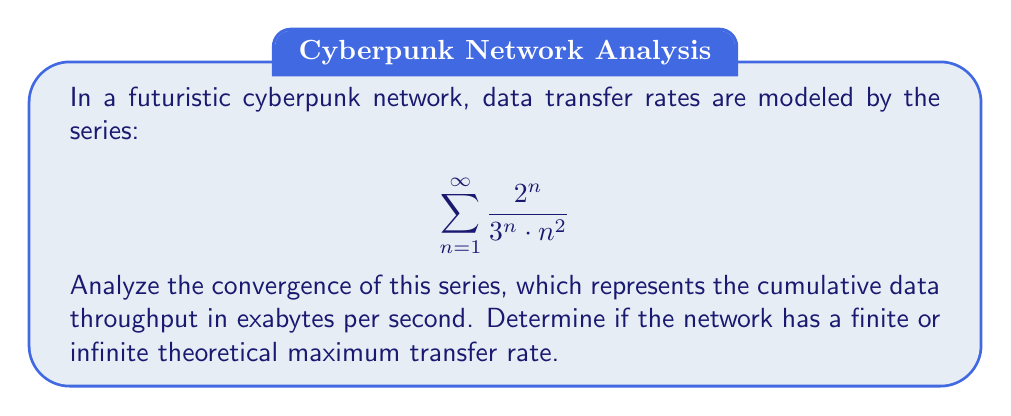Teach me how to tackle this problem. To analyze the convergence of this series, we'll use the ratio test:

1) First, let's define $a_n = \frac{2^n}{3^n \cdot n^2}$

2) Now, we compute the limit of the ratio of consecutive terms:

   $$\lim_{n \to \infty} \left|\frac{a_{n+1}}{a_n}\right| = \lim_{n \to \infty} \left|\frac{\frac{2^{n+1}}{3^{n+1} \cdot (n+1)^2}}{\frac{2^n}{3^n \cdot n^2}}\right|$$

3) Simplify:
   
   $$\lim_{n \to \infty} \left|\frac{2^{n+1}}{3^{n+1} \cdot (n+1)^2} \cdot \frac{3^n \cdot n^2}{2^n}\right| = \lim_{n \to \infty} \left|\frac{2}{3} \cdot \frac{n^2}{(n+1)^2}\right|$$

4) Evaluate the limit:
   
   $$\lim_{n \to \infty} \frac{2}{3} \cdot \frac{n^2}{(n+1)^2} = \frac{2}{3} \cdot \lim_{n \to \infty} \frac{n^2}{(n+1)^2} = \frac{2}{3} \cdot 1 = \frac{2}{3}$$

5) Since $\frac{2}{3} < 1$, by the ratio test, the series converges.

Therefore, the series converges to a finite sum, indicating that the network has a finite theoretical maximum transfer rate.
Answer: The series converges, implying that the futuristic network has a finite theoretical maximum transfer rate. 